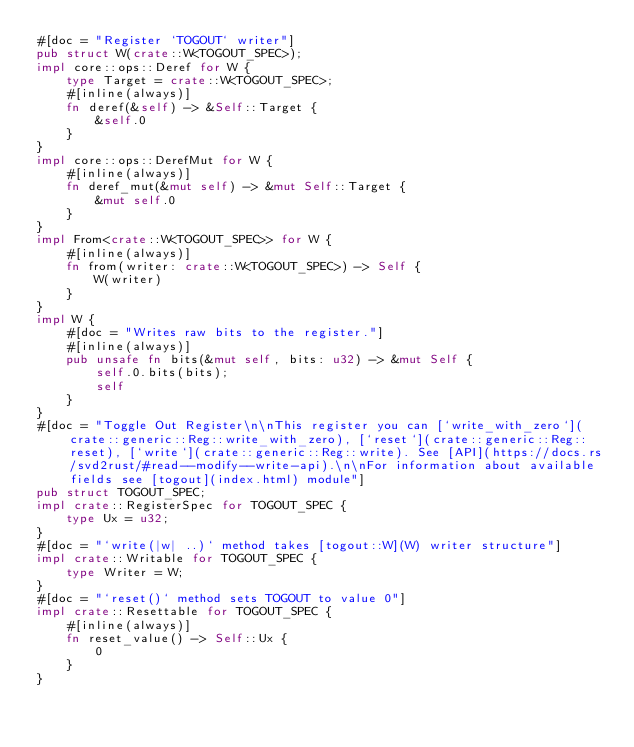<code> <loc_0><loc_0><loc_500><loc_500><_Rust_>#[doc = "Register `TOGOUT` writer"]
pub struct W(crate::W<TOGOUT_SPEC>);
impl core::ops::Deref for W {
    type Target = crate::W<TOGOUT_SPEC>;
    #[inline(always)]
    fn deref(&self) -> &Self::Target {
        &self.0
    }
}
impl core::ops::DerefMut for W {
    #[inline(always)]
    fn deref_mut(&mut self) -> &mut Self::Target {
        &mut self.0
    }
}
impl From<crate::W<TOGOUT_SPEC>> for W {
    #[inline(always)]
    fn from(writer: crate::W<TOGOUT_SPEC>) -> Self {
        W(writer)
    }
}
impl W {
    #[doc = "Writes raw bits to the register."]
    #[inline(always)]
    pub unsafe fn bits(&mut self, bits: u32) -> &mut Self {
        self.0.bits(bits);
        self
    }
}
#[doc = "Toggle Out Register\n\nThis register you can [`write_with_zero`](crate::generic::Reg::write_with_zero), [`reset`](crate::generic::Reg::reset), [`write`](crate::generic::Reg::write). See [API](https://docs.rs/svd2rust/#read--modify--write-api).\n\nFor information about available fields see [togout](index.html) module"]
pub struct TOGOUT_SPEC;
impl crate::RegisterSpec for TOGOUT_SPEC {
    type Ux = u32;
}
#[doc = "`write(|w| ..)` method takes [togout::W](W) writer structure"]
impl crate::Writable for TOGOUT_SPEC {
    type Writer = W;
}
#[doc = "`reset()` method sets TOGOUT to value 0"]
impl crate::Resettable for TOGOUT_SPEC {
    #[inline(always)]
    fn reset_value() -> Self::Ux {
        0
    }
}
</code> 